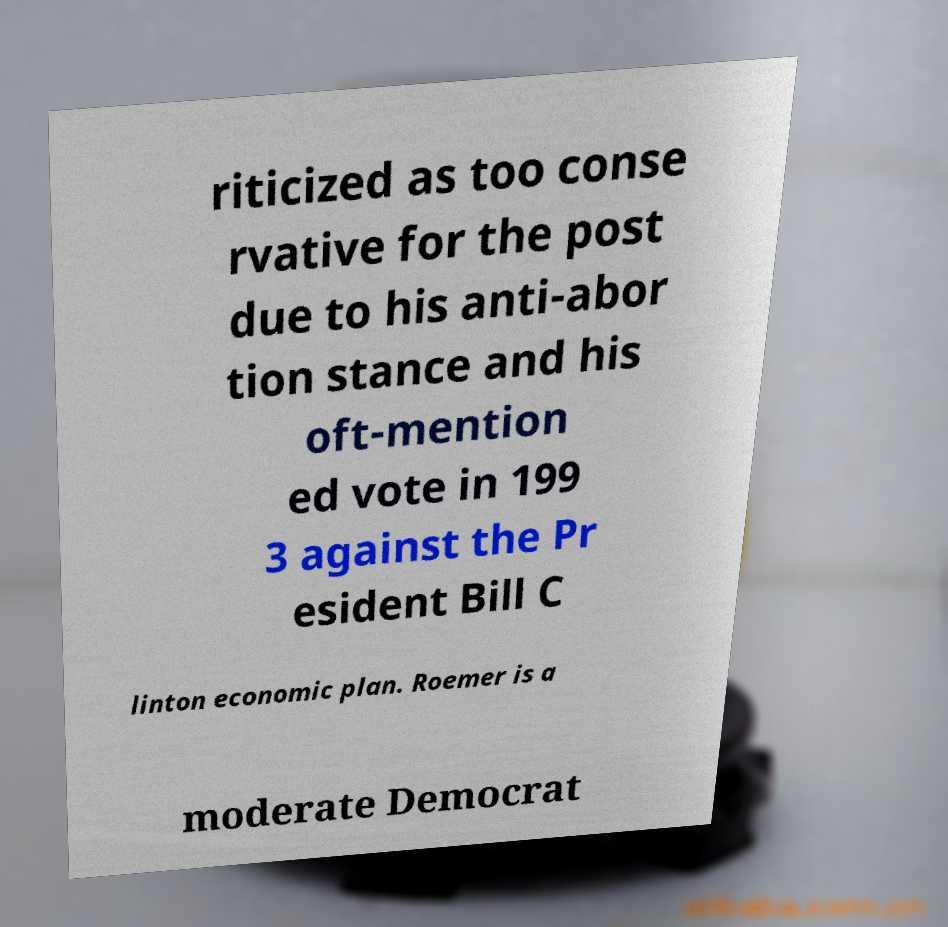Can you accurately transcribe the text from the provided image for me? riticized as too conse rvative for the post due to his anti-abor tion stance and his oft-mention ed vote in 199 3 against the Pr esident Bill C linton economic plan. Roemer is a moderate Democrat 